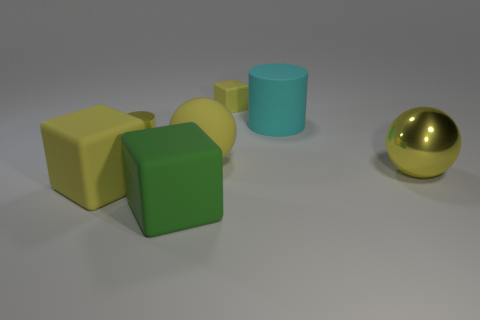What is the shape of the large yellow object that is in front of the metal ball?
Give a very brief answer. Cube. What number of yellow matte spheres are there?
Make the answer very short. 1. What is the color of the other large block that is made of the same material as the large green block?
Your answer should be very brief. Yellow. How many big objects are spheres or cyan cylinders?
Your response must be concise. 3. There is a big metallic thing; how many large yellow metallic things are left of it?
Offer a terse response. 0. What color is the other shiny thing that is the same shape as the cyan thing?
Provide a short and direct response. Yellow. What number of metal objects are gray cylinders or small yellow cubes?
Your answer should be very brief. 0. Are there any yellow metallic objects to the right of the cyan rubber object on the left side of the metallic thing that is on the right side of the green rubber thing?
Offer a terse response. Yes. The big rubber cylinder has what color?
Your answer should be compact. Cyan. Does the yellow matte object behind the big cyan rubber cylinder have the same shape as the green thing?
Your answer should be compact. Yes. 